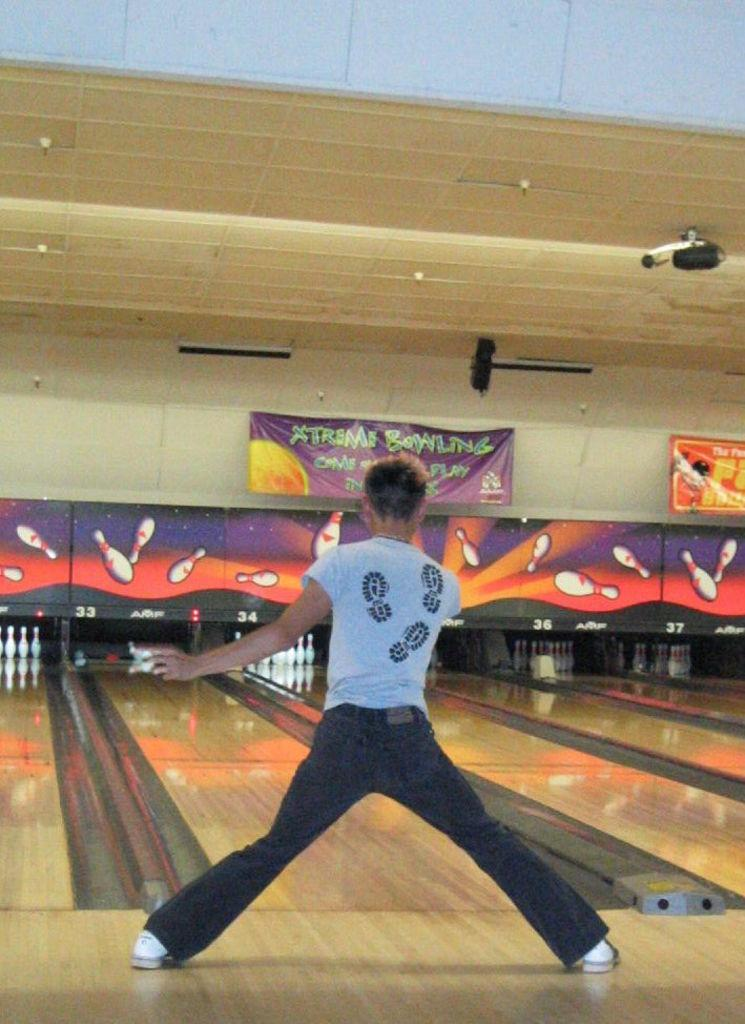What is the person in the image wearing? The person in the image is wearing a dress. What can be seen in the background of the image? There are bowling-pins and banners in the background of the image. What is visible at the top of the image? There are lights visible at the top of the image. How many ladybugs can be seen flying around the person in the image? There are no ladybugs present in the image. What type of liquid is being poured from the lights at the top of the image? There is no liquid visible in the image; only lights are present at the top. 